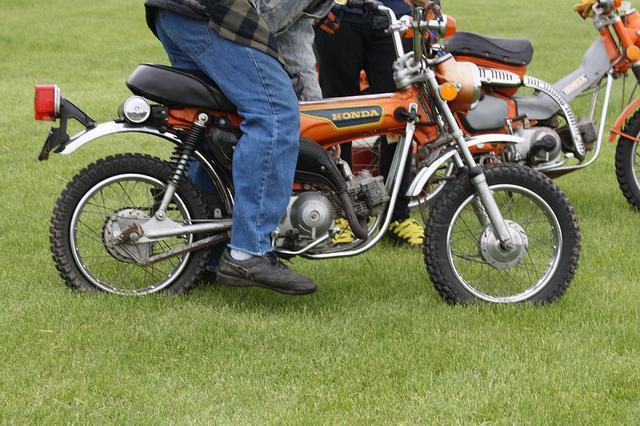How many motorcycles can you see?
Give a very brief answer. 2. How many people are visible?
Give a very brief answer. 2. How many arched windows are there to the left of the clock tower?
Give a very brief answer. 0. 